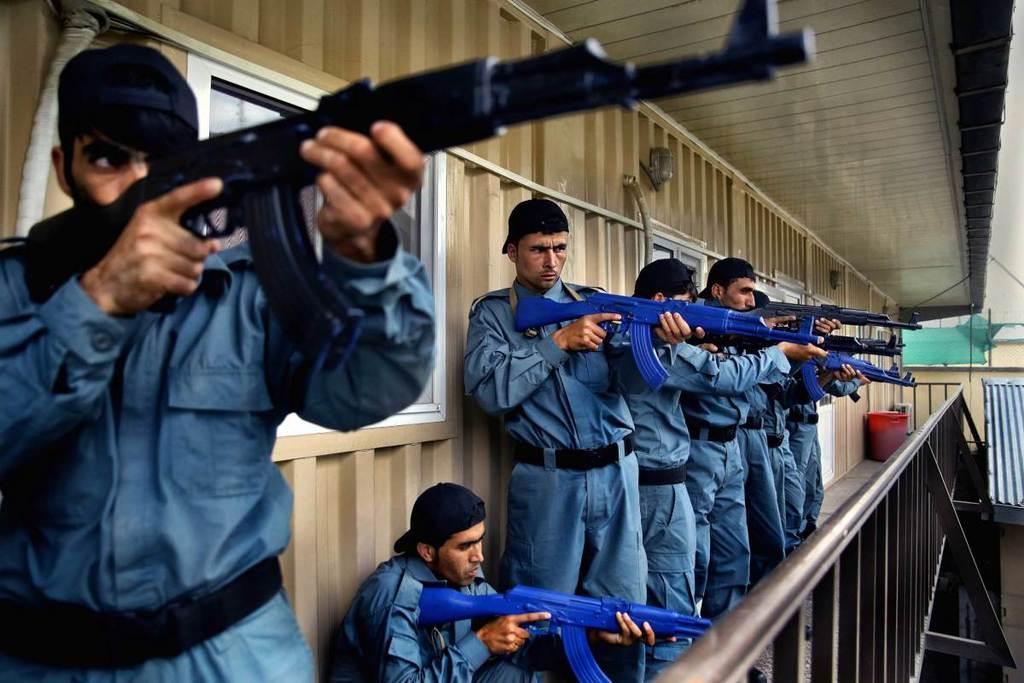In one or two sentences, can you explain what this image depicts? In this picture we can see a group of people are standing in the balcony and a person is in squat position and the people are holding the guns. Behind the people there is a wall with windows and in the balcony there is a red plastic container. 